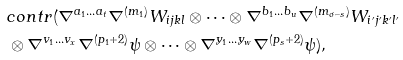<formula> <loc_0><loc_0><loc_500><loc_500>& c o n t r ( \nabla ^ { a _ { 1 } \dots a _ { t } } \nabla ^ { ( m _ { 1 } ) } W _ { i j k l } \otimes \dots \otimes \nabla ^ { b _ { 1 } \dots b _ { u } } \nabla ^ { ( m _ { \sigma - s } ) } W _ { i ^ { \prime } j ^ { \prime } k ^ { \prime } l ^ { \prime } } \\ & \otimes \nabla ^ { v _ { 1 } \dots v _ { x } } \nabla ^ { ( p _ { 1 } + 2 ) } \psi \otimes \dots \otimes \nabla ^ { y _ { 1 } \dots y _ { w } } \nabla ^ { ( p _ { s } + 2 ) } \psi ) ,</formula> 